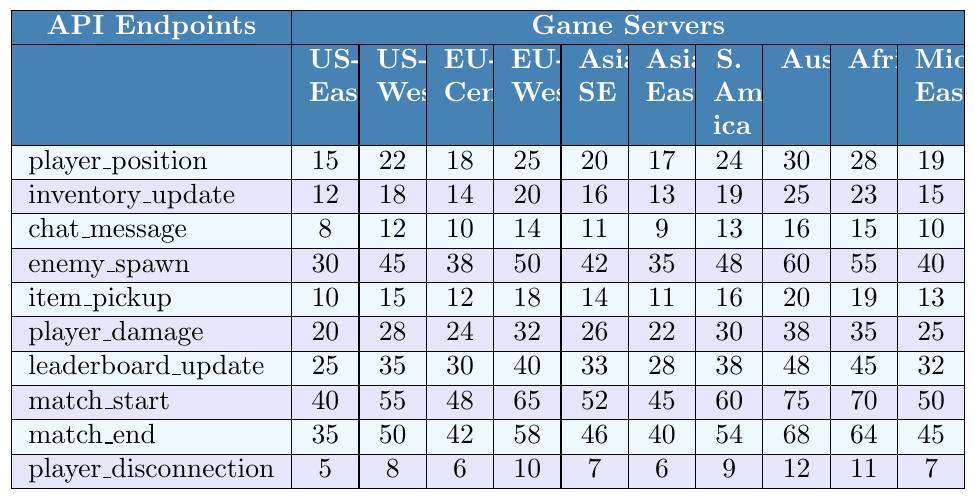What is the response time for the 'player_position' API endpoint on the 'EU-West' server? Looking at the row for 'player_position' and the column for 'EU-West', the response time is 25 ms.
Answer: 25 ms What is the fastest response time recorded for the 'chat_message' endpoint? In the 'chat_message' row, the smallest response time is 8 ms.
Answer: 8 ms What is the average response time for the 'player_damage' endpoint across all servers? The response times for 'player_damage' are 20, 28, 24, 32, 26, 22, 30, 38, 35, 25. Summing these values gives 25 + 35 + 38 + 30 + 22 + 26 + 32 + 24 + 28 + 20 =  256. There are 10 values, so we divide 256 by 10 which gives an average of 25.6 ms.
Answer: 25.6 ms Which API endpoint has the highest response time on the 'Middle East' server? Reviewing the 'Middle East' column, the endpoint with the highest response time is 'match_start' with 50 ms.
Answer: match_start Is the response time for 'player_disconnection' more than 10 ms on any server? By checking the row for 'player_disconnection', the response times are 5, 8, 6, 10, 7, 6, 9, 12, 11, 7. The only server that exceeds 10 ms is 'Australia' with a response time of 12 ms, thus yes.
Answer: Yes What is the difference in response time between 'enemy_spawn' on 'Asia-Southeast' and 'EU-Central'? The response time for 'enemy_spawn' is 42 ms for 'Asia-Southeast' and 38 ms for 'EU-Central'. The difference is 42 - 38 = 4 ms.
Answer: 4 ms Which server has the slowest overall response times across all API endpoints? To find the slowest server, we add up the response times for each server: US-East = 15+12+8+30+10+20+25+40+35+5 = 175; US-West = 22+18+12+45+15+28+35+55+50+8 = 288; EU-Central = 18+14+10+38+12+24+30+48+42+6 = 292; EU-West = 25+20+14+50+18+32+40+65+58+10 = 302; Asia-Southeast = 20+16+11+42+14+26+33+52+46+7 =  327; Asia-East = 17+13+9+35+11+22+28+45+40+6 =  56; South America = 24+19+13+48+16+30+38+60+54+9 =  66; Australia = 30+25+16+60+20+38+48+75+68+12 =  56; Africa = 28+23+15+55+19+35+45+70+64+11 =  309; Middle East = 19+15+10+40+13+25+32+50+45+7 =  276. The slowest is Asia-Southeast with 327 ms.
Answer: Asia-Southeast What is the median response time for the 'inventory_update' endpoint across all servers? The response times for 'inventory_update' are 12, 18, 14, 20, 16, 13, 19, 25, 23, 15. Sorting these gives 12, 13, 14, 15, 16, 18, 19, 20, 23, 25, so the median (the average of the 5th and 6th values) is (16 + 18) / 2 = 17 ms.
Answer: 17 ms Does the 'item_pickup' response time exceed 30 ms on any server? Checking the row for 'item_pickup', the highest value is 20 ms, which does not exceed 30 ms for any server.
Answer: No 